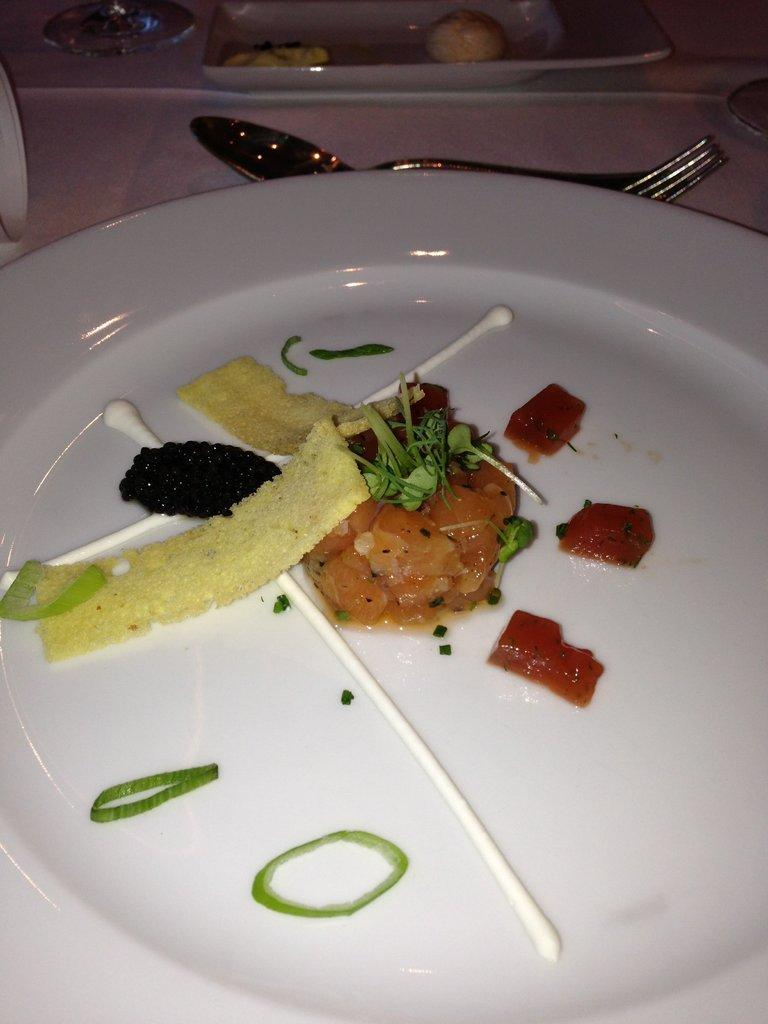What is on the plate that is visible in the image? There is a food item on the plate in the image. What is the color of the plate? The plate is white. What else can be seen on the cloth in the image? There are items placed on a cloth in the image. What type of items are visible on the cloth? There are eatable things visible in the image. Can you see a donkey carrying a basket in the image? No, there is no donkey or basket present in the image. 